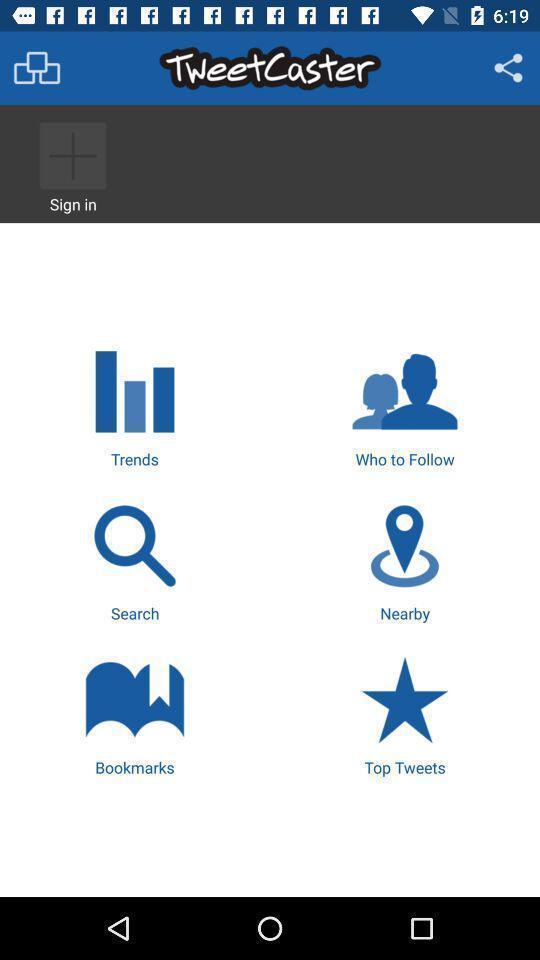Provide a detailed account of this screenshot. Various options displayed of an interaction app. 